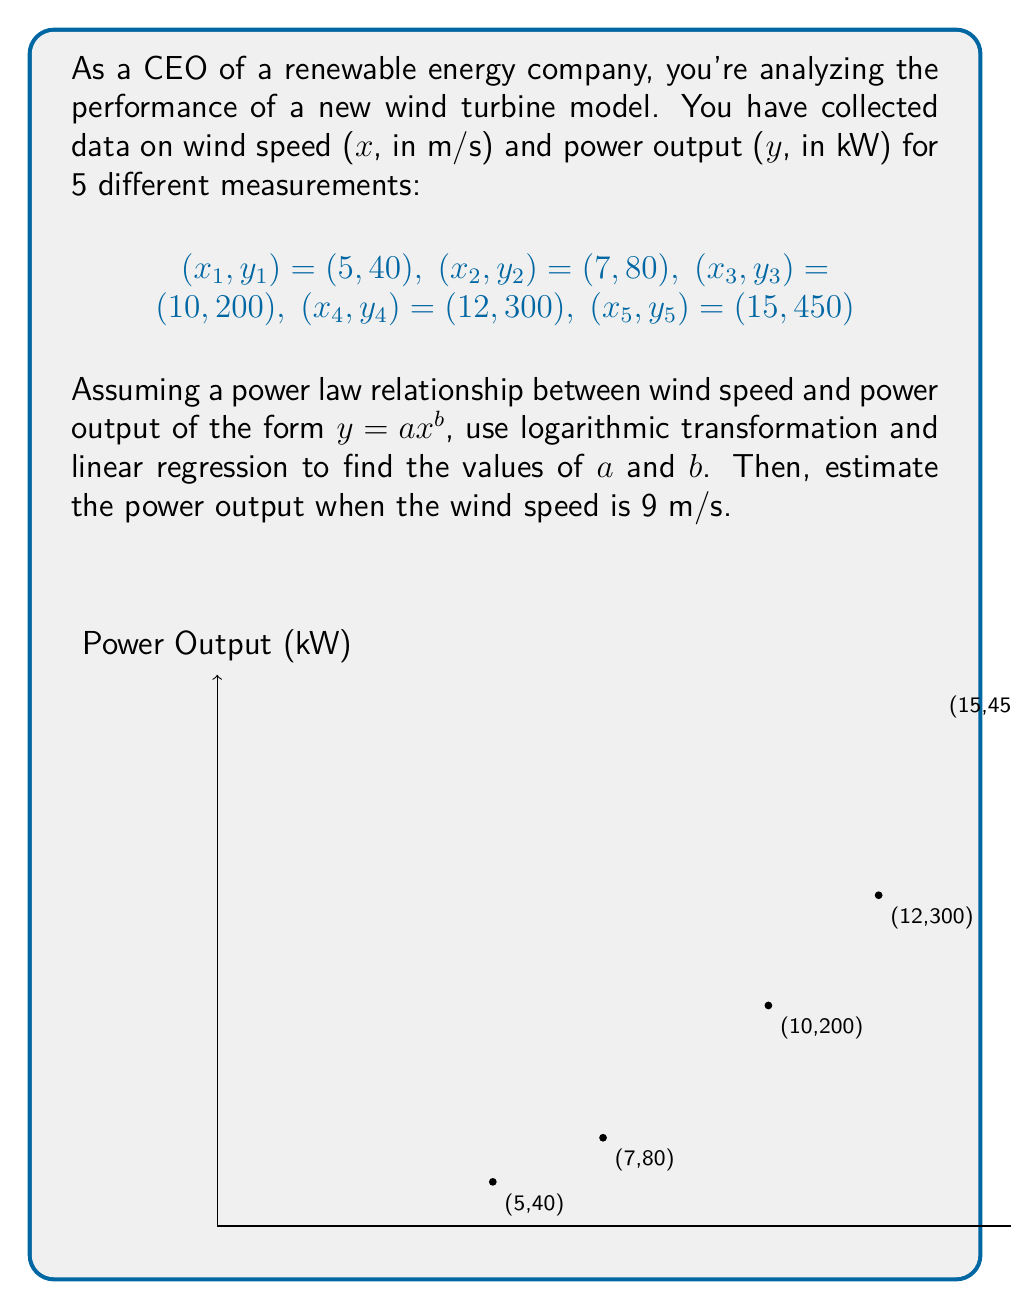Give your solution to this math problem. 1) First, we apply logarithmic transformation to the power law equation:
   $$y = ax^b$$
   $$\log(y) = \log(a) + b\log(x)$$

   Let $Y = \log(y)$, $X = \log(x)$, and $A = \log(a)$. Then we have:
   $$Y = A + bX$$

2) Now we can apply linear regression to find $A$ and $b$. We need to calculate:
   $$X_i = \log(x_i)$$ and $$Y_i = \log(y_i)$$ for each data point.

3) Calculate the means:
   $$\bar{X} = \frac{1}{5}\sum_{i=1}^5 X_i$$
   $$\bar{Y} = \frac{1}{5}\sum_{i=1}^5 Y_i$$

4) Calculate the slope $b$:
   $$b = \frac{\sum_{i=1}^5 (X_i - \bar{X})(Y_i - \bar{Y})}{\sum_{i=1}^5 (X_i - \bar{X})^2}$$

5) Calculate the y-intercept $A$:
   $$A = \bar{Y} - b\bar{X}$$

6) After calculation, we get:
   $$b \approx 2.1541$$ and $$A \approx -0.8951$$

7) Since $A = \log(a)$, we can find $a$:
   $$a = e^A \approx 0.4087$$

8) Now we have the power law equation:
   $$y \approx 0.4087x^{2.1541}$$

9) To estimate the power output when wind speed is 9 m/s, we substitute x = 9:
   $$y \approx 0.4087 \cdot 9^{2.1541} \approx 151.8 \text{ kW}$$
Answer: $a \approx 0.4087$, $b \approx 2.1541$, Estimated power output at 9 m/s $\approx 151.8$ kW 